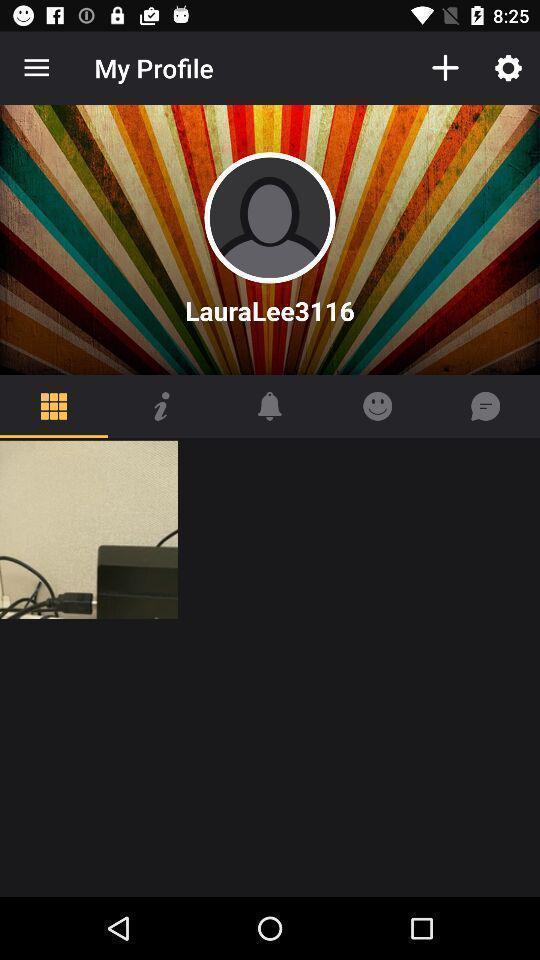What can you discern from this picture? Page showing profile option in a social networking website. 